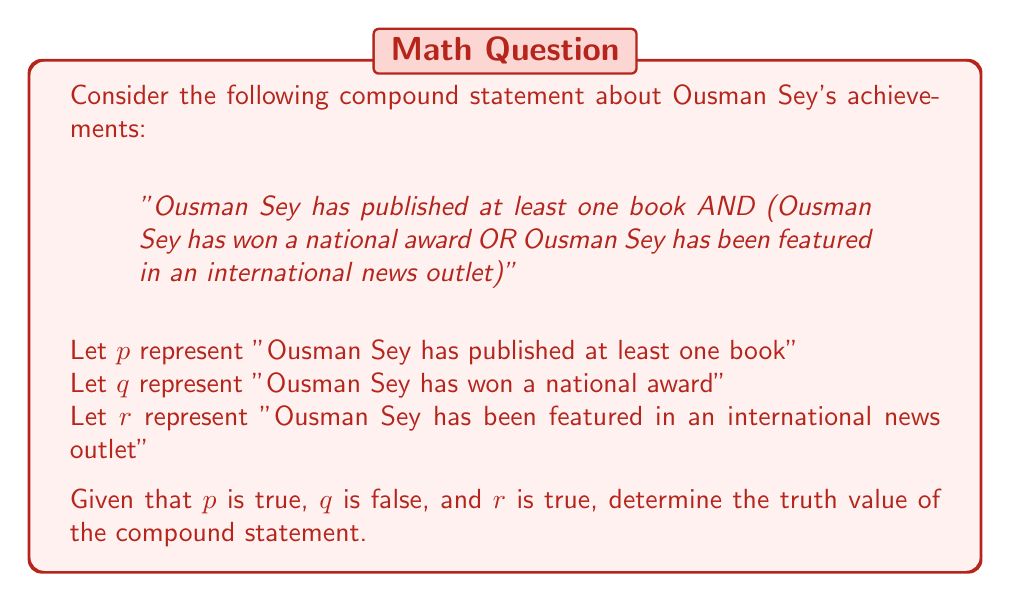Help me with this question. Let's approach this step-by-step using Boolean algebra:

1. The compound statement can be represented as: $p \land (q \lor r)$

2. We are given the following truth values:
   $p$ = true
   $q$ = false
   $r$ = true

3. Let's evaluate the inner parentheses first: $(q \lor r)$
   $false \lor true = true$

4. Now we have: $p \land true$

5. Substituting the value of $p$:
   $true \land true = true$

Therefore, the entire compound statement evaluates to true.
Answer: True 